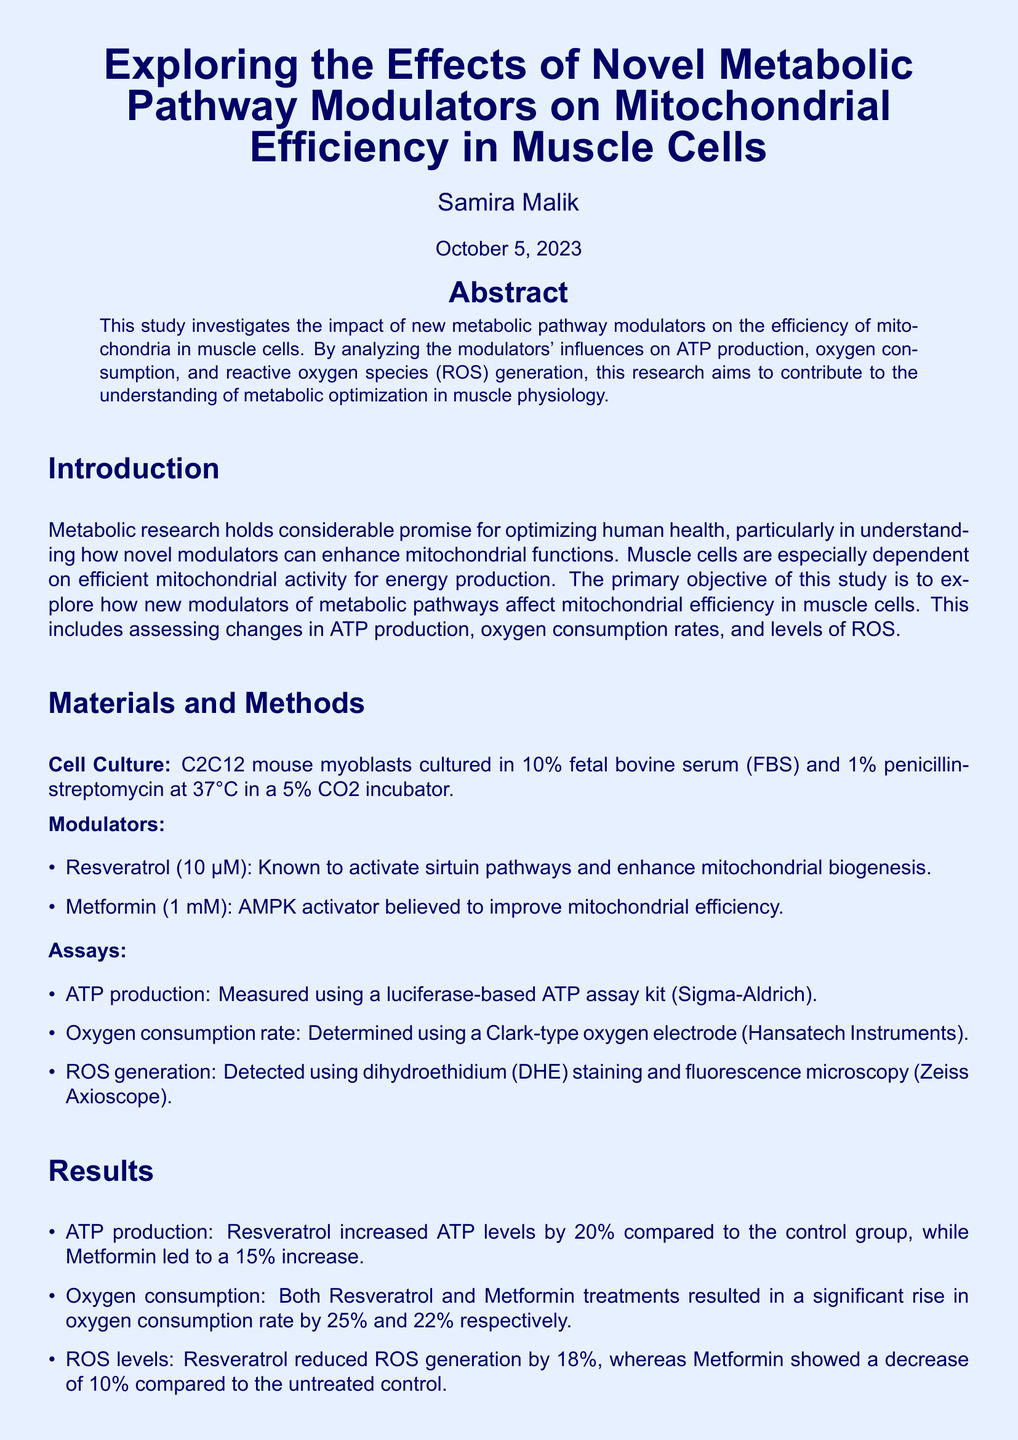What is the primary objective of the study? The primary objective is to explore how new modulators of metabolic pathways affect mitochondrial efficiency in muscle cells.
Answer: To explore how new modulators of metabolic pathways affect mitochondrial efficiency in muscle cells What cell type was used in this experiment? The experiment used C2C12 mouse myoblasts cultured for analysis.
Answer: C2C12 mouse myoblasts How much did Resveratrol increase ATP levels compared to the control? Resveratrol increased ATP levels by 20% compared to the control group.
Answer: 20% What method was used to measure oxygen consumption? The oxygen consumption rate was measured using a Clark-type oxygen electrode.
Answer: Clark-type oxygen electrode Which modulator showed a greater reduction in ROS levels? Resveratrol reduced ROS generation more than Metformin, showing an 18% decrease.
Answer: Resveratrol What was the incubation condition for the cell culture? The cells were incubated at 37°C in a 5% CO2 incubator.
Answer: 37°C in a 5% CO2 incubator What are the names of the modulators tested in this study? The modulators tested were Resveratrol and Metformin.
Answer: Resveratrol and Metformin What percentage increase in oxygen consumption did Metformin cause? Metformin led to a 22% increase in oxygen consumption rate.
Answer: 22% 